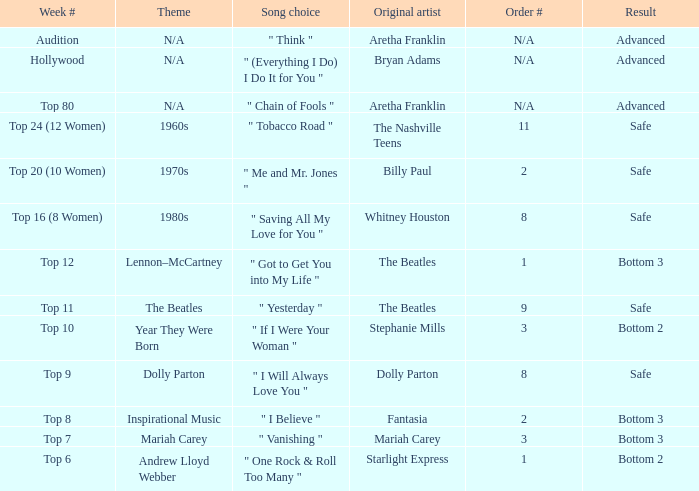What is the week number related to andrew lloyd webber? Top 6. 